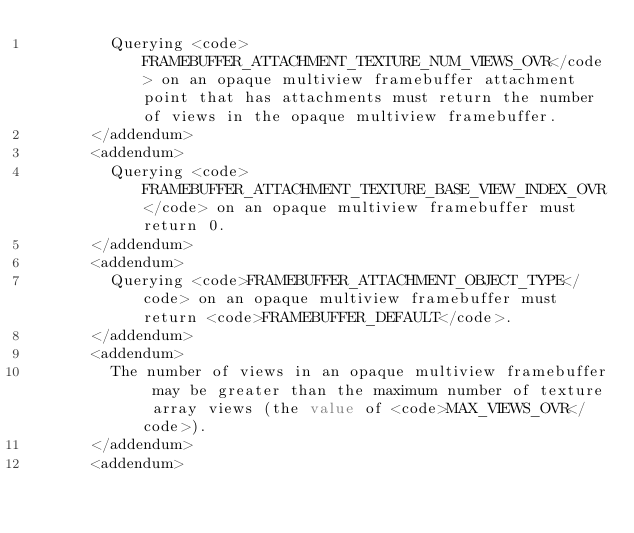Convert code to text. <code><loc_0><loc_0><loc_500><loc_500><_XML_>        Querying <code>FRAMEBUFFER_ATTACHMENT_TEXTURE_NUM_VIEWS_OVR</code> on an opaque multiview framebuffer attachment point that has attachments must return the number of views in the opaque multiview framebuffer.
      </addendum>
      <addendum>
        Querying <code>FRAMEBUFFER_ATTACHMENT_TEXTURE_BASE_VIEW_INDEX_OVR</code> on an opaque multiview framebuffer must return 0.
      </addendum>
      <addendum>
        Querying <code>FRAMEBUFFER_ATTACHMENT_OBJECT_TYPE</code> on an opaque multiview framebuffer must return <code>FRAMEBUFFER_DEFAULT</code>.
      </addendum>
      <addendum>
        The number of views in an opaque multiview framebuffer may be greater than the maximum number of texture array views (the value of <code>MAX_VIEWS_OVR</code>).
      </addendum>
      <addendum></code> 